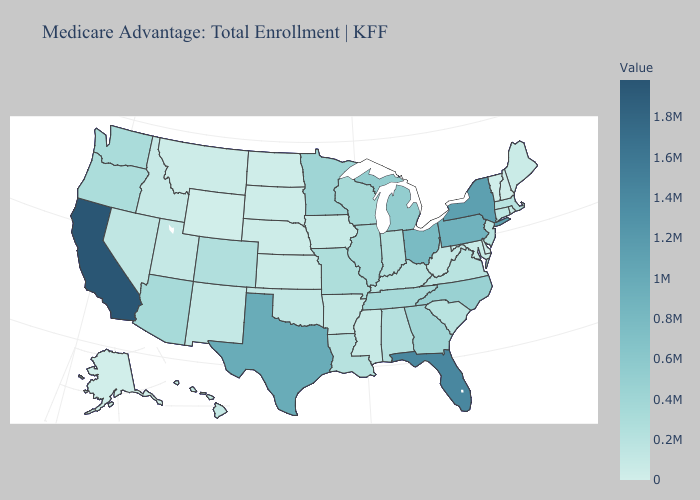Does Ohio have the highest value in the MidWest?
Short answer required. Yes. Does Delaware have a lower value than Arizona?
Keep it brief. Yes. Among the states that border Arizona , does Colorado have the lowest value?
Short answer required. No. Does Vermont have the lowest value in the Northeast?
Write a very short answer. Yes. Among the states that border Georgia , which have the lowest value?
Short answer required. South Carolina. 